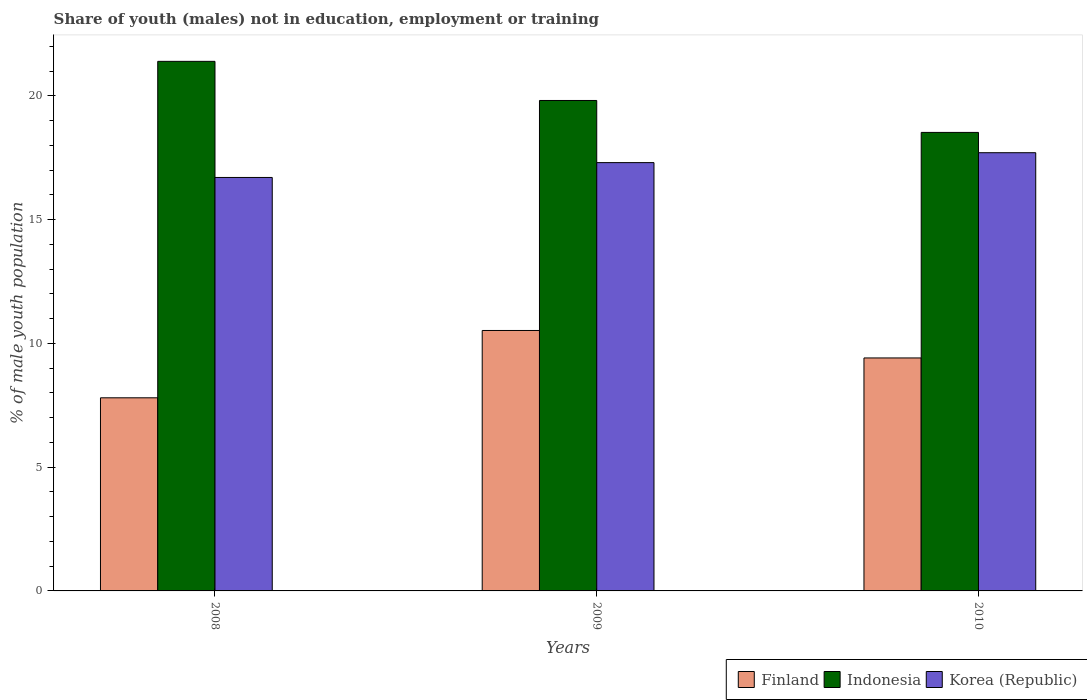How many different coloured bars are there?
Provide a short and direct response. 3. How many groups of bars are there?
Give a very brief answer. 3. What is the label of the 2nd group of bars from the left?
Your answer should be compact. 2009. What is the percentage of unemployed males population in in Indonesia in 2010?
Keep it short and to the point. 18.52. Across all years, what is the maximum percentage of unemployed males population in in Indonesia?
Ensure brevity in your answer.  21.39. Across all years, what is the minimum percentage of unemployed males population in in Indonesia?
Give a very brief answer. 18.52. In which year was the percentage of unemployed males population in in Finland maximum?
Provide a succinct answer. 2009. What is the total percentage of unemployed males population in in Indonesia in the graph?
Offer a very short reply. 59.72. What is the difference between the percentage of unemployed males population in in Indonesia in 2009 and that in 2010?
Your response must be concise. 1.29. What is the difference between the percentage of unemployed males population in in Finland in 2008 and the percentage of unemployed males population in in Indonesia in 2009?
Make the answer very short. -12.01. What is the average percentage of unemployed males population in in Indonesia per year?
Provide a short and direct response. 19.91. In the year 2010, what is the difference between the percentage of unemployed males population in in Indonesia and percentage of unemployed males population in in Finland?
Provide a succinct answer. 9.11. What is the ratio of the percentage of unemployed males population in in Indonesia in 2008 to that in 2009?
Ensure brevity in your answer.  1.08. Is the percentage of unemployed males population in in Korea (Republic) in 2009 less than that in 2010?
Your answer should be compact. Yes. Is the difference between the percentage of unemployed males population in in Indonesia in 2008 and 2009 greater than the difference between the percentage of unemployed males population in in Finland in 2008 and 2009?
Your answer should be very brief. Yes. What is the difference between the highest and the second highest percentage of unemployed males population in in Korea (Republic)?
Ensure brevity in your answer.  0.4. What is the difference between the highest and the lowest percentage of unemployed males population in in Indonesia?
Offer a very short reply. 2.87. What does the 1st bar from the right in 2008 represents?
Provide a short and direct response. Korea (Republic). Are all the bars in the graph horizontal?
Your answer should be compact. No. What is the difference between two consecutive major ticks on the Y-axis?
Offer a very short reply. 5. Where does the legend appear in the graph?
Give a very brief answer. Bottom right. How many legend labels are there?
Ensure brevity in your answer.  3. How are the legend labels stacked?
Offer a terse response. Horizontal. What is the title of the graph?
Your response must be concise. Share of youth (males) not in education, employment or training. What is the label or title of the Y-axis?
Provide a succinct answer. % of male youth population. What is the % of male youth population of Finland in 2008?
Your answer should be very brief. 7.8. What is the % of male youth population in Indonesia in 2008?
Offer a very short reply. 21.39. What is the % of male youth population of Korea (Republic) in 2008?
Give a very brief answer. 16.7. What is the % of male youth population in Finland in 2009?
Your answer should be very brief. 10.52. What is the % of male youth population in Indonesia in 2009?
Keep it short and to the point. 19.81. What is the % of male youth population in Korea (Republic) in 2009?
Keep it short and to the point. 17.3. What is the % of male youth population in Finland in 2010?
Offer a terse response. 9.41. What is the % of male youth population of Indonesia in 2010?
Ensure brevity in your answer.  18.52. What is the % of male youth population in Korea (Republic) in 2010?
Give a very brief answer. 17.7. Across all years, what is the maximum % of male youth population of Finland?
Provide a succinct answer. 10.52. Across all years, what is the maximum % of male youth population in Indonesia?
Your response must be concise. 21.39. Across all years, what is the maximum % of male youth population in Korea (Republic)?
Give a very brief answer. 17.7. Across all years, what is the minimum % of male youth population in Finland?
Ensure brevity in your answer.  7.8. Across all years, what is the minimum % of male youth population in Indonesia?
Make the answer very short. 18.52. Across all years, what is the minimum % of male youth population of Korea (Republic)?
Offer a terse response. 16.7. What is the total % of male youth population of Finland in the graph?
Make the answer very short. 27.73. What is the total % of male youth population in Indonesia in the graph?
Your answer should be very brief. 59.72. What is the total % of male youth population in Korea (Republic) in the graph?
Keep it short and to the point. 51.7. What is the difference between the % of male youth population of Finland in 2008 and that in 2009?
Give a very brief answer. -2.72. What is the difference between the % of male youth population of Indonesia in 2008 and that in 2009?
Your answer should be compact. 1.58. What is the difference between the % of male youth population of Korea (Republic) in 2008 and that in 2009?
Provide a succinct answer. -0.6. What is the difference between the % of male youth population of Finland in 2008 and that in 2010?
Your answer should be very brief. -1.61. What is the difference between the % of male youth population of Indonesia in 2008 and that in 2010?
Offer a very short reply. 2.87. What is the difference between the % of male youth population in Korea (Republic) in 2008 and that in 2010?
Offer a terse response. -1. What is the difference between the % of male youth population of Finland in 2009 and that in 2010?
Ensure brevity in your answer.  1.11. What is the difference between the % of male youth population of Indonesia in 2009 and that in 2010?
Offer a terse response. 1.29. What is the difference between the % of male youth population in Finland in 2008 and the % of male youth population in Indonesia in 2009?
Make the answer very short. -12.01. What is the difference between the % of male youth population in Indonesia in 2008 and the % of male youth population in Korea (Republic) in 2009?
Your response must be concise. 4.09. What is the difference between the % of male youth population of Finland in 2008 and the % of male youth population of Indonesia in 2010?
Your answer should be compact. -10.72. What is the difference between the % of male youth population in Finland in 2008 and the % of male youth population in Korea (Republic) in 2010?
Offer a terse response. -9.9. What is the difference between the % of male youth population of Indonesia in 2008 and the % of male youth population of Korea (Republic) in 2010?
Provide a short and direct response. 3.69. What is the difference between the % of male youth population in Finland in 2009 and the % of male youth population in Korea (Republic) in 2010?
Offer a very short reply. -7.18. What is the difference between the % of male youth population in Indonesia in 2009 and the % of male youth population in Korea (Republic) in 2010?
Ensure brevity in your answer.  2.11. What is the average % of male youth population of Finland per year?
Your answer should be very brief. 9.24. What is the average % of male youth population in Indonesia per year?
Provide a short and direct response. 19.91. What is the average % of male youth population in Korea (Republic) per year?
Provide a succinct answer. 17.23. In the year 2008, what is the difference between the % of male youth population of Finland and % of male youth population of Indonesia?
Make the answer very short. -13.59. In the year 2008, what is the difference between the % of male youth population in Indonesia and % of male youth population in Korea (Republic)?
Your response must be concise. 4.69. In the year 2009, what is the difference between the % of male youth population in Finland and % of male youth population in Indonesia?
Ensure brevity in your answer.  -9.29. In the year 2009, what is the difference between the % of male youth population in Finland and % of male youth population in Korea (Republic)?
Provide a short and direct response. -6.78. In the year 2009, what is the difference between the % of male youth population of Indonesia and % of male youth population of Korea (Republic)?
Your answer should be compact. 2.51. In the year 2010, what is the difference between the % of male youth population in Finland and % of male youth population in Indonesia?
Your answer should be compact. -9.11. In the year 2010, what is the difference between the % of male youth population of Finland and % of male youth population of Korea (Republic)?
Your answer should be very brief. -8.29. In the year 2010, what is the difference between the % of male youth population in Indonesia and % of male youth population in Korea (Republic)?
Make the answer very short. 0.82. What is the ratio of the % of male youth population of Finland in 2008 to that in 2009?
Your answer should be very brief. 0.74. What is the ratio of the % of male youth population of Indonesia in 2008 to that in 2009?
Provide a short and direct response. 1.08. What is the ratio of the % of male youth population of Korea (Republic) in 2008 to that in 2009?
Provide a succinct answer. 0.97. What is the ratio of the % of male youth population of Finland in 2008 to that in 2010?
Provide a succinct answer. 0.83. What is the ratio of the % of male youth population of Indonesia in 2008 to that in 2010?
Your answer should be compact. 1.16. What is the ratio of the % of male youth population of Korea (Republic) in 2008 to that in 2010?
Your response must be concise. 0.94. What is the ratio of the % of male youth population of Finland in 2009 to that in 2010?
Ensure brevity in your answer.  1.12. What is the ratio of the % of male youth population of Indonesia in 2009 to that in 2010?
Give a very brief answer. 1.07. What is the ratio of the % of male youth population of Korea (Republic) in 2009 to that in 2010?
Keep it short and to the point. 0.98. What is the difference between the highest and the second highest % of male youth population in Finland?
Your response must be concise. 1.11. What is the difference between the highest and the second highest % of male youth population of Indonesia?
Offer a very short reply. 1.58. What is the difference between the highest and the second highest % of male youth population in Korea (Republic)?
Your answer should be very brief. 0.4. What is the difference between the highest and the lowest % of male youth population of Finland?
Provide a short and direct response. 2.72. What is the difference between the highest and the lowest % of male youth population of Indonesia?
Your answer should be compact. 2.87. What is the difference between the highest and the lowest % of male youth population in Korea (Republic)?
Provide a short and direct response. 1. 